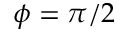<formula> <loc_0><loc_0><loc_500><loc_500>\phi = \pi / 2</formula> 